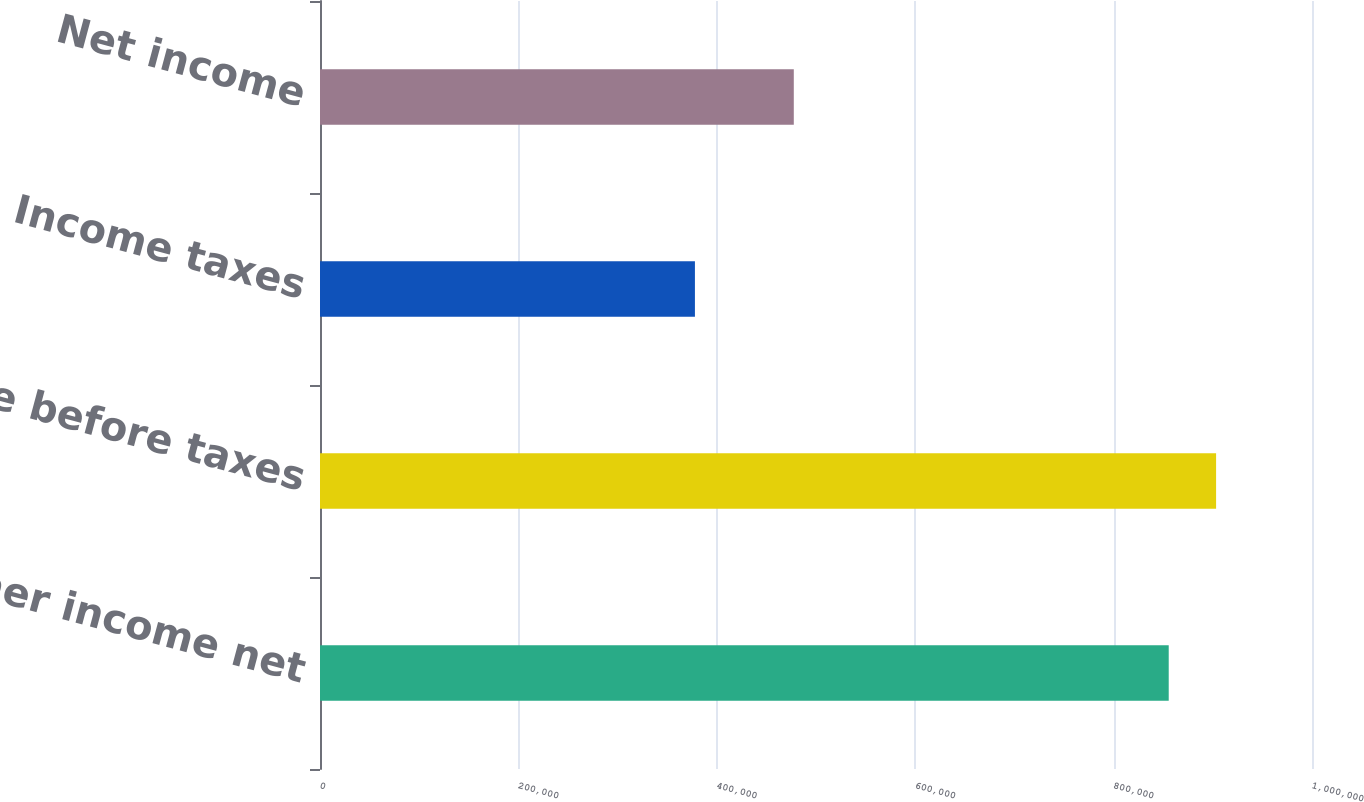Convert chart to OTSL. <chart><loc_0><loc_0><loc_500><loc_500><bar_chart><fcel>Other income net<fcel>Income before taxes<fcel>Income taxes<fcel>Net income<nl><fcel>855564<fcel>903326<fcel>377949<fcel>477615<nl></chart> 